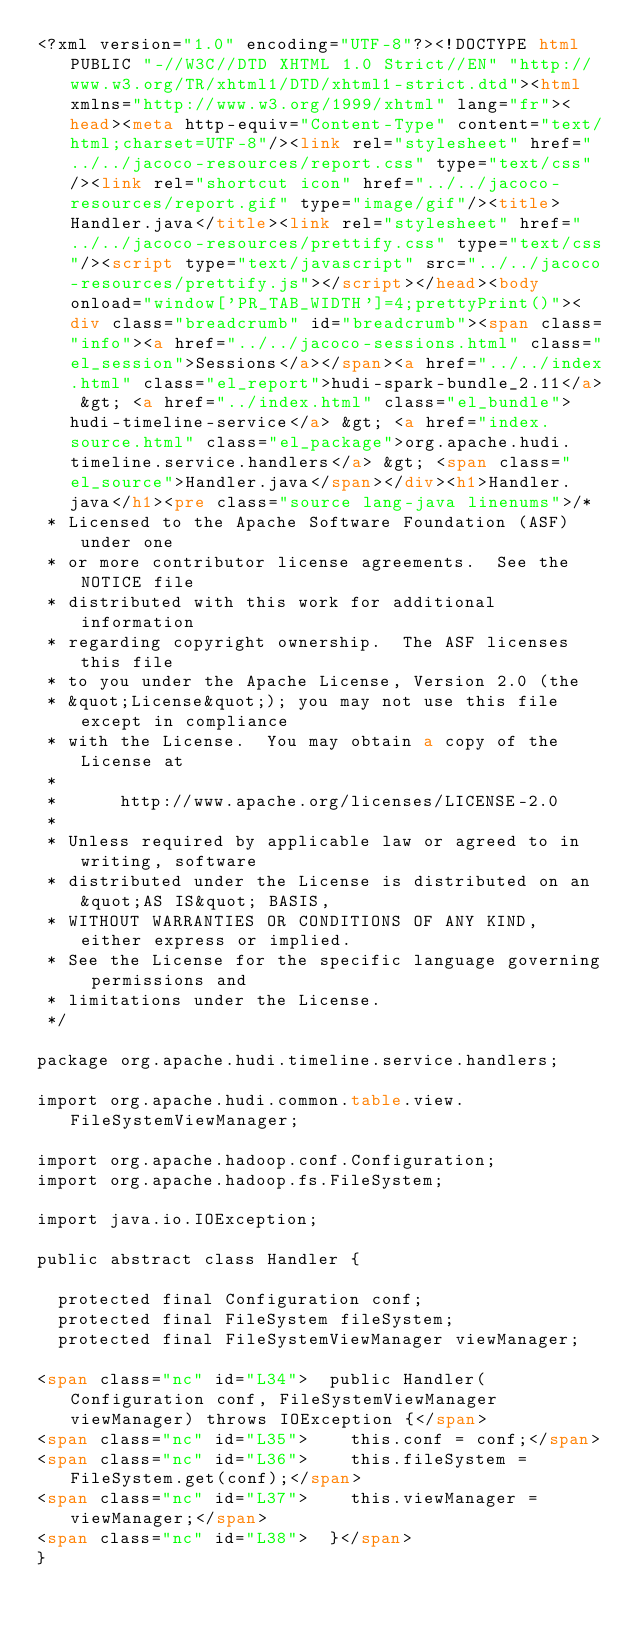<code> <loc_0><loc_0><loc_500><loc_500><_HTML_><?xml version="1.0" encoding="UTF-8"?><!DOCTYPE html PUBLIC "-//W3C//DTD XHTML 1.0 Strict//EN" "http://www.w3.org/TR/xhtml1/DTD/xhtml1-strict.dtd"><html xmlns="http://www.w3.org/1999/xhtml" lang="fr"><head><meta http-equiv="Content-Type" content="text/html;charset=UTF-8"/><link rel="stylesheet" href="../../jacoco-resources/report.css" type="text/css"/><link rel="shortcut icon" href="../../jacoco-resources/report.gif" type="image/gif"/><title>Handler.java</title><link rel="stylesheet" href="../../jacoco-resources/prettify.css" type="text/css"/><script type="text/javascript" src="../../jacoco-resources/prettify.js"></script></head><body onload="window['PR_TAB_WIDTH']=4;prettyPrint()"><div class="breadcrumb" id="breadcrumb"><span class="info"><a href="../../jacoco-sessions.html" class="el_session">Sessions</a></span><a href="../../index.html" class="el_report">hudi-spark-bundle_2.11</a> &gt; <a href="../index.html" class="el_bundle">hudi-timeline-service</a> &gt; <a href="index.source.html" class="el_package">org.apache.hudi.timeline.service.handlers</a> &gt; <span class="el_source">Handler.java</span></div><h1>Handler.java</h1><pre class="source lang-java linenums">/*
 * Licensed to the Apache Software Foundation (ASF) under one
 * or more contributor license agreements.  See the NOTICE file
 * distributed with this work for additional information
 * regarding copyright ownership.  The ASF licenses this file
 * to you under the Apache License, Version 2.0 (the
 * &quot;License&quot;); you may not use this file except in compliance
 * with the License.  You may obtain a copy of the License at
 *
 *      http://www.apache.org/licenses/LICENSE-2.0
 *
 * Unless required by applicable law or agreed to in writing, software
 * distributed under the License is distributed on an &quot;AS IS&quot; BASIS,
 * WITHOUT WARRANTIES OR CONDITIONS OF ANY KIND, either express or implied.
 * See the License for the specific language governing permissions and
 * limitations under the License.
 */

package org.apache.hudi.timeline.service.handlers;

import org.apache.hudi.common.table.view.FileSystemViewManager;

import org.apache.hadoop.conf.Configuration;
import org.apache.hadoop.fs.FileSystem;

import java.io.IOException;

public abstract class Handler {

  protected final Configuration conf;
  protected final FileSystem fileSystem;
  protected final FileSystemViewManager viewManager;

<span class="nc" id="L34">  public Handler(Configuration conf, FileSystemViewManager viewManager) throws IOException {</span>
<span class="nc" id="L35">    this.conf = conf;</span>
<span class="nc" id="L36">    this.fileSystem = FileSystem.get(conf);</span>
<span class="nc" id="L37">    this.viewManager = viewManager;</span>
<span class="nc" id="L38">  }</span>
}</code> 